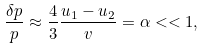<formula> <loc_0><loc_0><loc_500><loc_500>\frac { \delta p } { p } \approx \frac { 4 } { 3 } \frac { u _ { 1 } - u _ { 2 } } { v } = \alpha < < 1 ,</formula> 